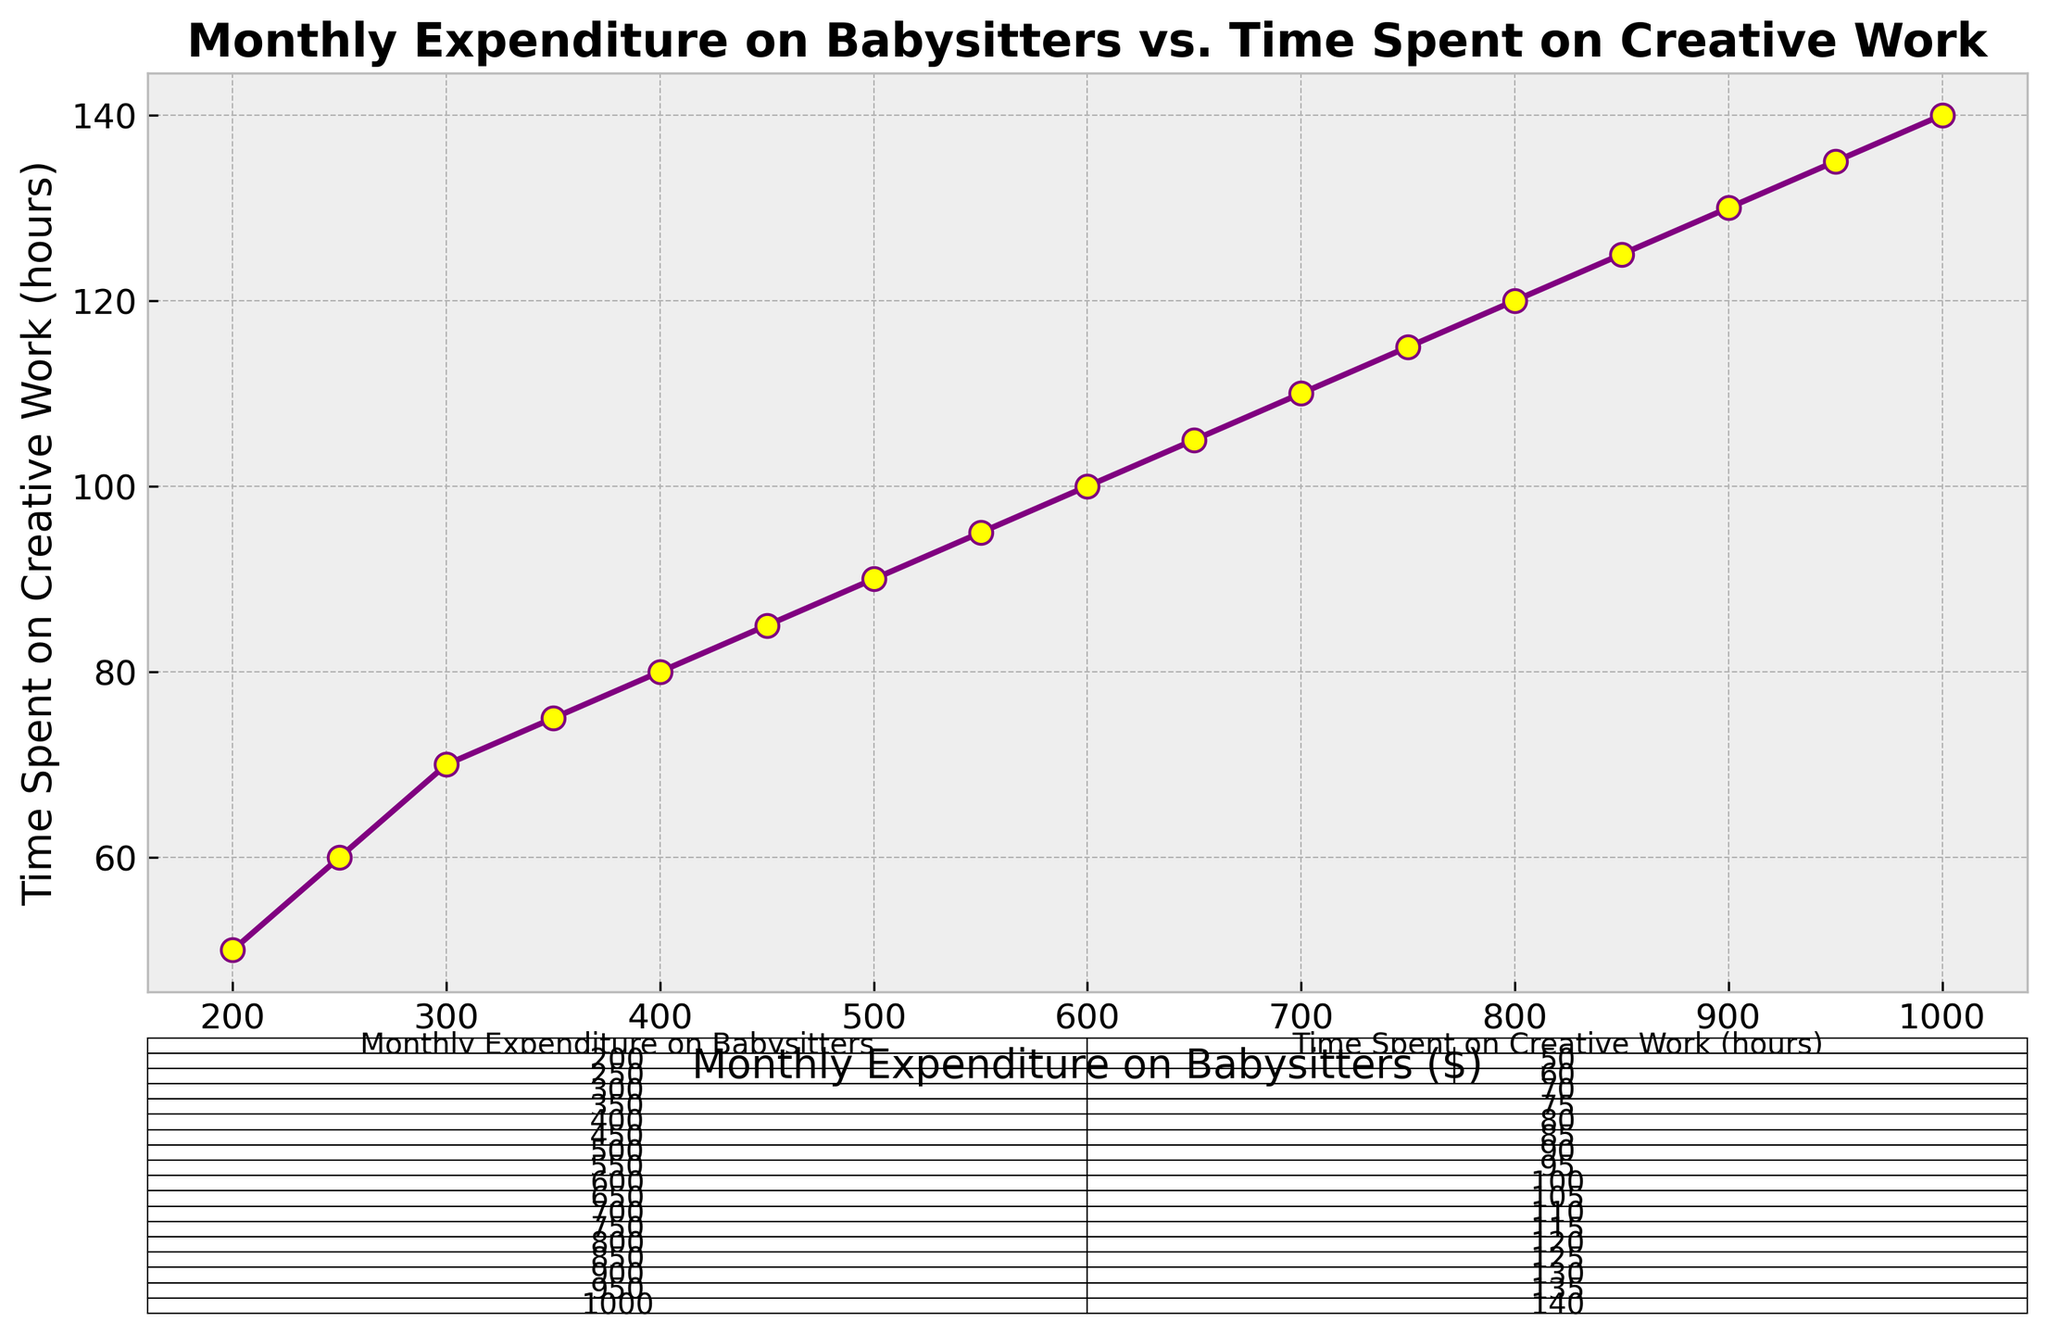How much does the freelance artist spend on babysitters when they work for 105 hours? According to the table, when the freelance artist works for 105 hours, the monthly expenditure on babysitters is $650.
Answer: $650 What is the difference in time spent on creative work between spending $200 and $400 on babysitters? From the table, the time spent on creative work at $200 expenditure is 50 hours, and at $400 expenditure is 80 hours. The difference is 80 - 50.
Answer: 30 hours Between $500 and $750 expenditure on babysitters, which amount corresponds to more creative work hours? From the table, $500 expenditure corresponds to 90 hours of creative work, while $750 corresponds to 115 hours of creative work. Since 115 > 90, $750 corresponds to more hours.
Answer: $750 What is the average monthly expenditure on babysitters for the given data set? Sum all the expenditure values (200, 250, 300, ..., 1000) and divide by the number of data points (17). The sum is 10200, so the average is 10200 / 17.
Answer: $600 If a freelance artist works for 135 hours, how much do they spend on babysitters? According to the table, working for 135 hours corresponds to a monthly expenditure of $950 on babysitters.
Answer: $950 Does the amount of time spent on creative work increase more rapidly after $300 expenditure or before it? By comparing the slope around $300 expenditure, the time spent on creative work increases by 20 hours from $250 to $300 and by 5 hours from $300 to $350, suggesting a more rapid increase before $300 expenditure.
Answer: Before $300 expenditure What is the total increase in creative work hours when the expenditure on babysitters increases from $200 to $1000? The creative work hours increase from 50 hours at $200 expenditure to 140 hours at $1000 expenditure. The total increase is 140 - 50.
Answer: 90 hours What is the median value of time spent on creative work? The total data points are 17, so the median is the 9th value in the ordered list. From the table, the 9th value for time spent on creative work is 100 hours.
Answer: 100 hours 